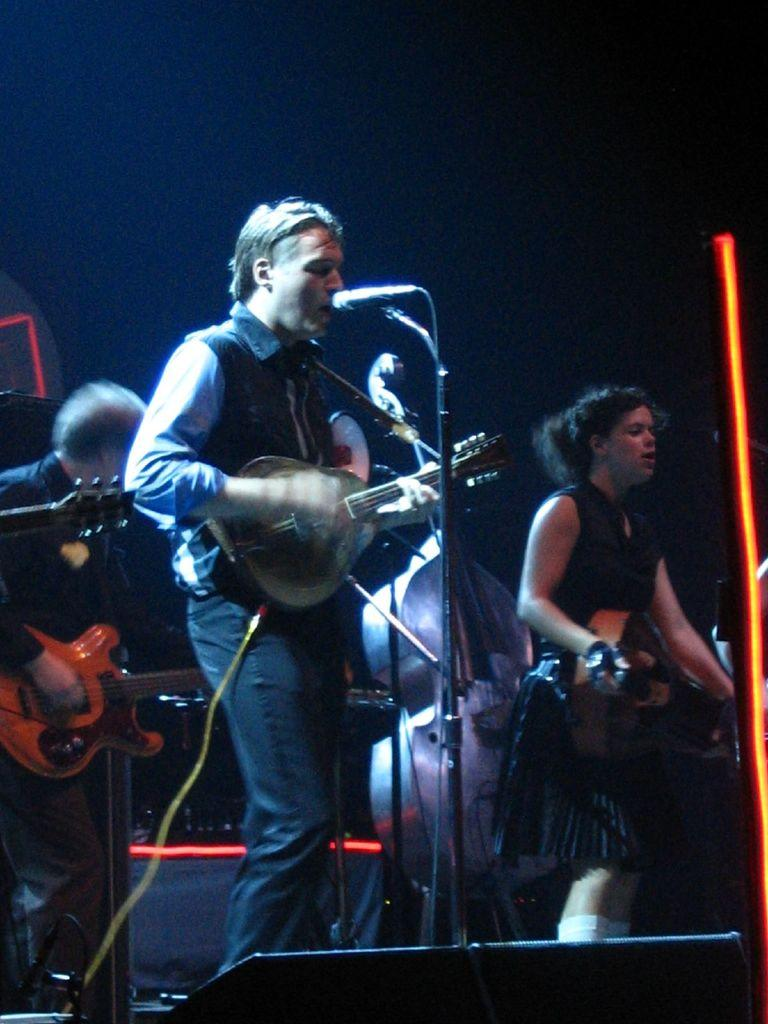How many people are in the image? There are two men and one woman in the image. What are the individuals doing in the image? They are playing a guitar and singing in front of a microphone. Where are they performing? They are on a stage. What type of disease is affecting the guitar in the image? There is no disease affecting the guitar in the image; it is being played by one of the individuals. 